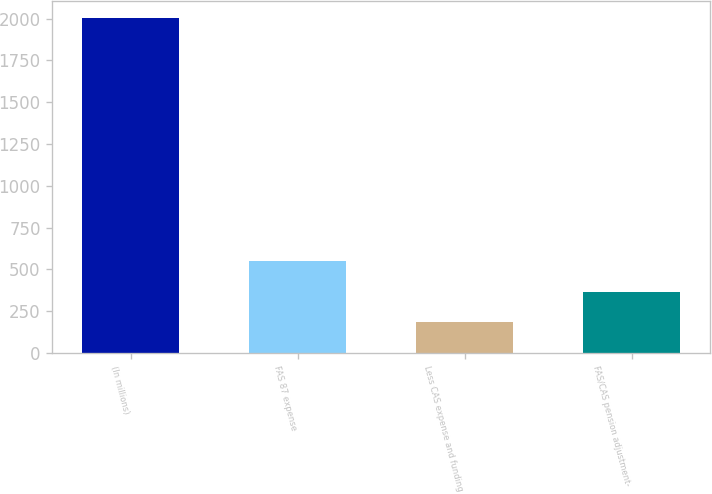<chart> <loc_0><loc_0><loc_500><loc_500><bar_chart><fcel>(In millions)<fcel>FAS 87 expense<fcel>Less CAS expense and funding<fcel>FAS/CAS pension adjustment-<nl><fcel>2003<fcel>547.8<fcel>184<fcel>365.9<nl></chart> 